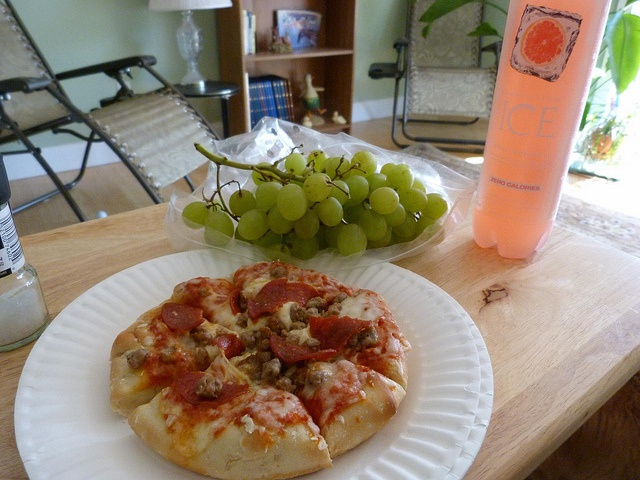Describe the objects in this image and their specific colors. I can see dining table in gray, darkgray, lightgray, tan, and olive tones, pizza in gray, maroon, and brown tones, bottle in gray, salmon, and lightpink tones, chair in gray, darkgray, and black tones, and chair in gray, darkgray, black, and darkgreen tones in this image. 